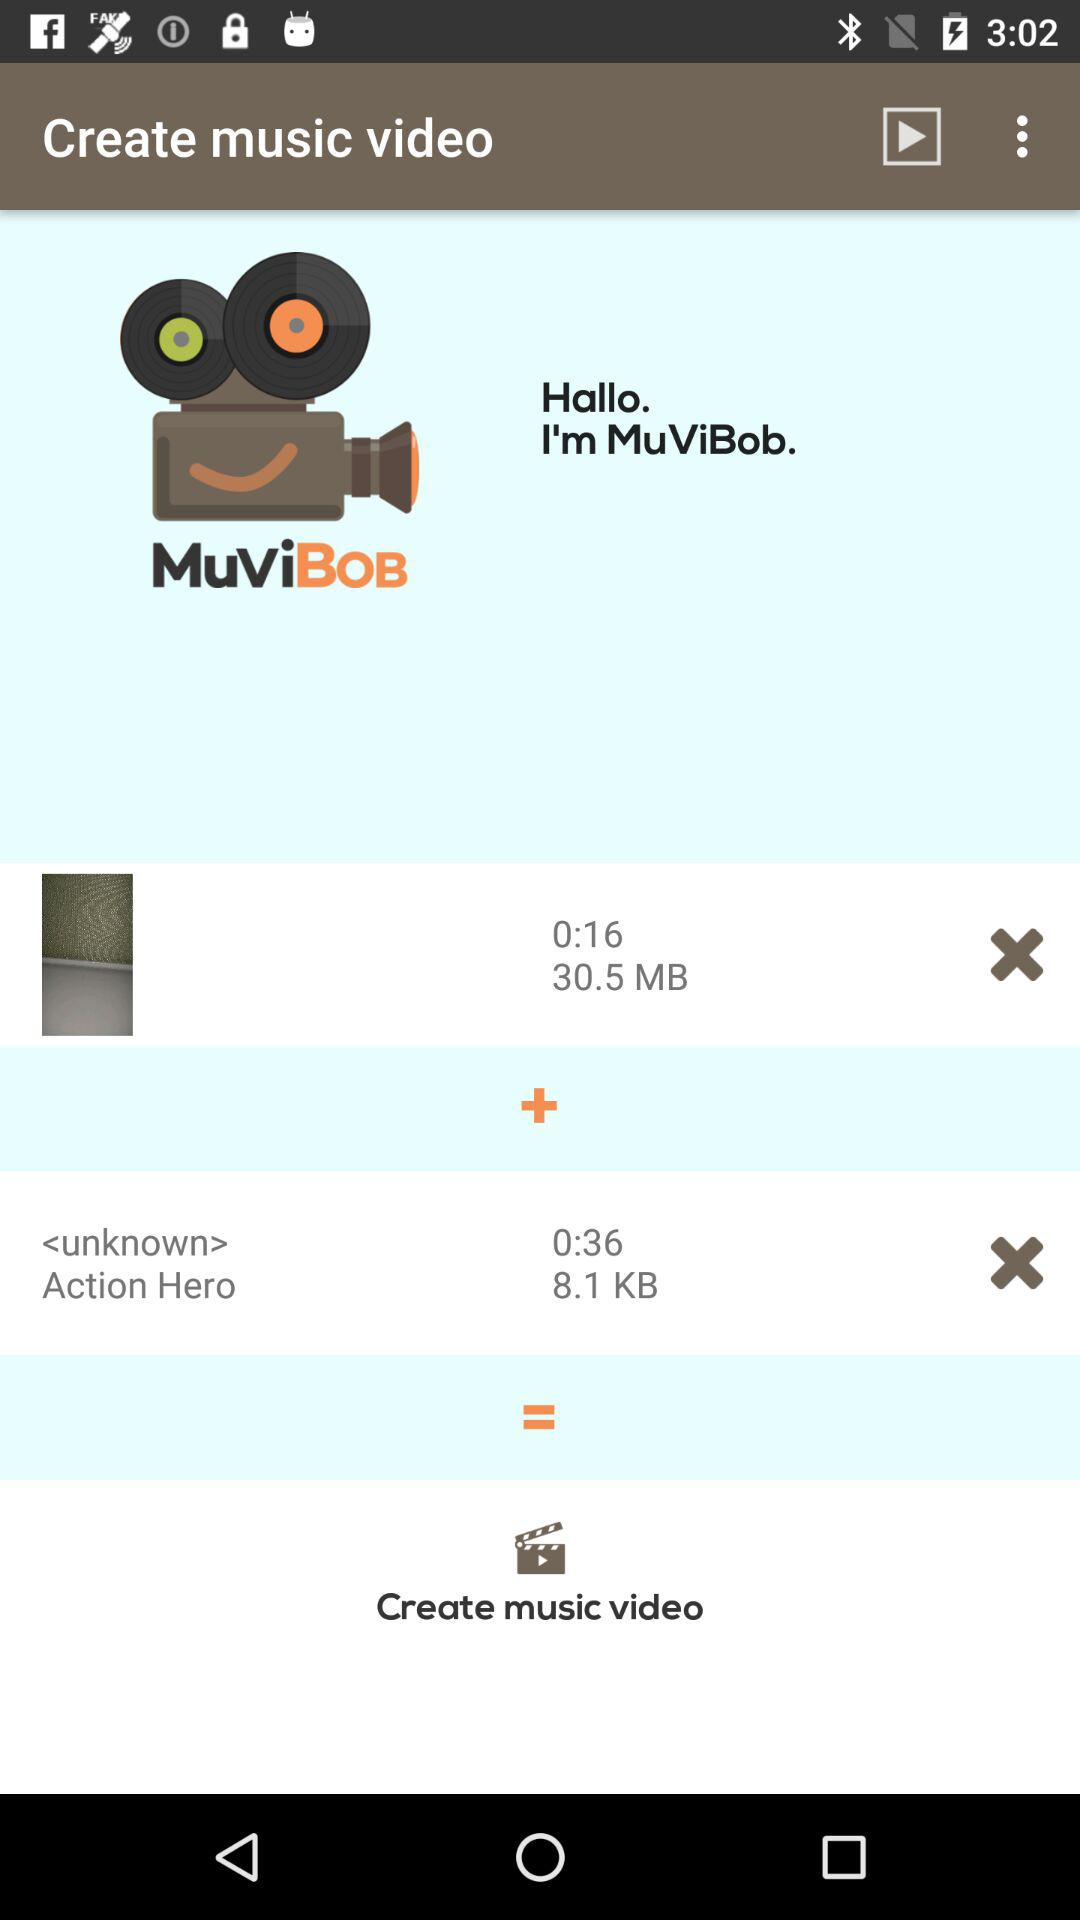What is the application name? The application name is "MuViBob". 